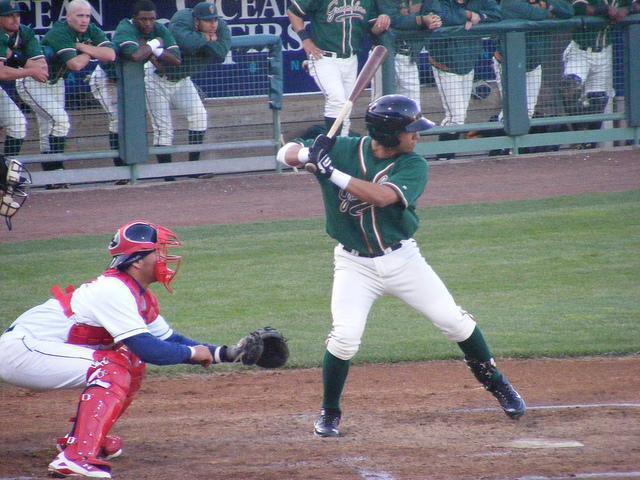How many of these people are professional baseball players?
Give a very brief answer. 11. How many people have face guards on?
Give a very brief answer. 1. How many people are in the picture?
Give a very brief answer. 11. How many buses are there?
Give a very brief answer. 0. 